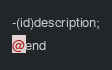Convert code to text. <code><loc_0><loc_0><loc_500><loc_500><_C_>-(id)description;
@end

</code> 